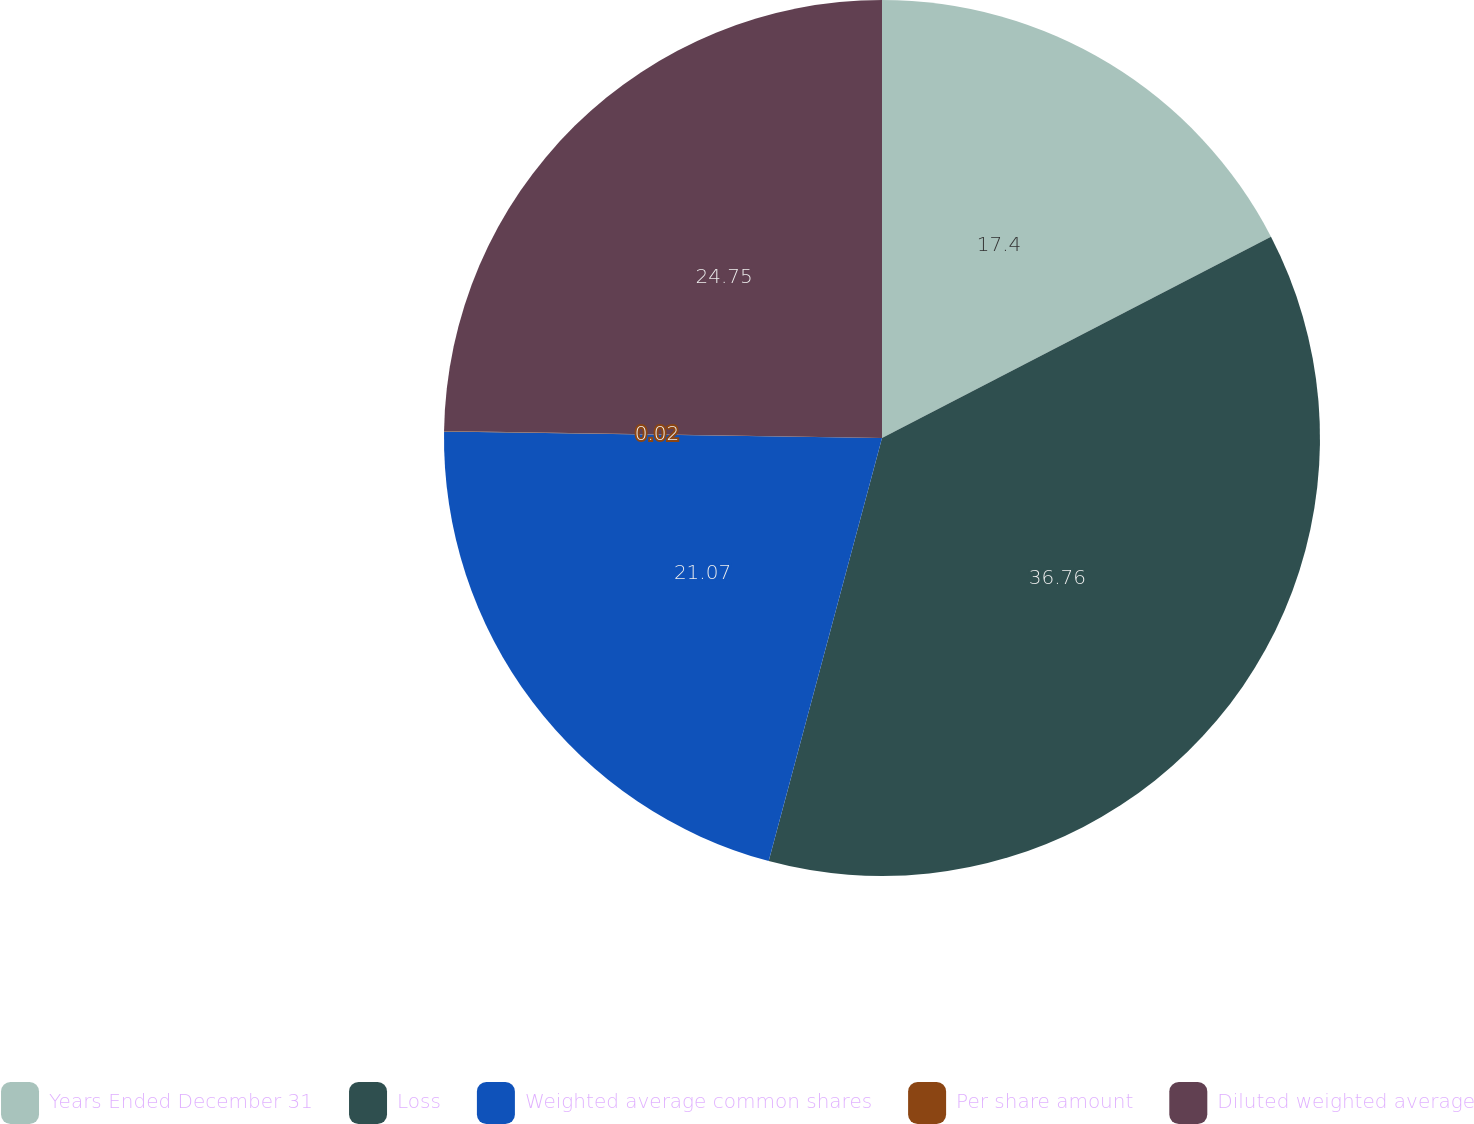Convert chart to OTSL. <chart><loc_0><loc_0><loc_500><loc_500><pie_chart><fcel>Years Ended December 31<fcel>Loss<fcel>Weighted average common shares<fcel>Per share amount<fcel>Diluted weighted average<nl><fcel>17.4%<fcel>36.77%<fcel>21.07%<fcel>0.02%<fcel>24.75%<nl></chart> 